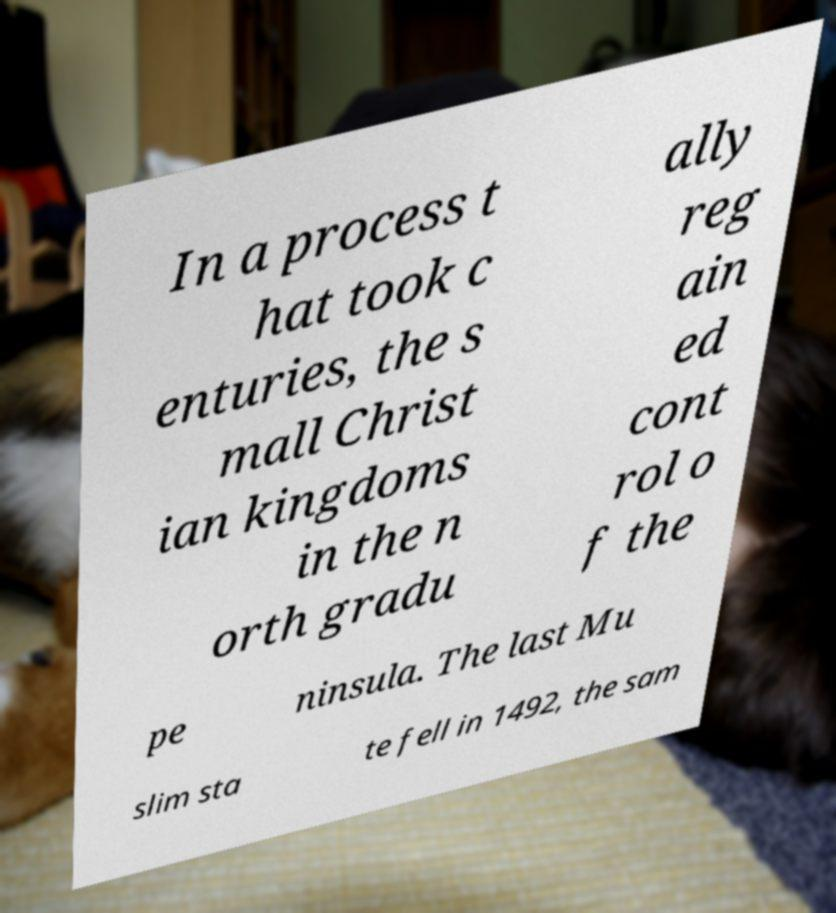Please identify and transcribe the text found in this image. In a process t hat took c enturies, the s mall Christ ian kingdoms in the n orth gradu ally reg ain ed cont rol o f the pe ninsula. The last Mu slim sta te fell in 1492, the sam 